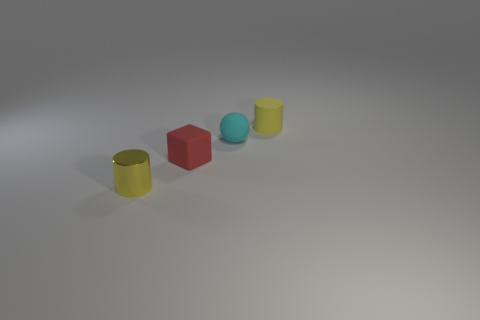Is the color of the shiny cylinder the same as the rubber cylinder?
Your answer should be compact. Yes. Is there a matte cylinder that is behind the tiny cylinder on the right side of the yellow thing left of the red object?
Keep it short and to the point. No. There is a cyan object that is the same size as the red cube; what shape is it?
Your answer should be compact. Sphere. What number of big objects are either yellow metal spheres or cyan balls?
Ensure brevity in your answer.  0. There is a block that is made of the same material as the cyan ball; what color is it?
Keep it short and to the point. Red. There is a yellow object in front of the cube; is its shape the same as the rubber object to the left of the rubber ball?
Offer a terse response. No. How many shiny things are either spheres or small gray spheres?
Provide a short and direct response. 0. There is another small cylinder that is the same color as the small matte cylinder; what is its material?
Make the answer very short. Metal. Are there any other things that have the same shape as the cyan object?
Offer a terse response. No. What material is the yellow object behind the small cyan sphere?
Ensure brevity in your answer.  Rubber. 